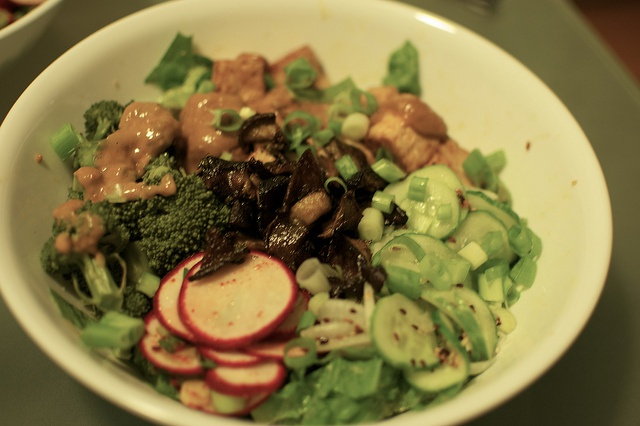Describe the objects in this image and their specific colors. I can see dining table in olive, khaki, black, and tan tones, bowl in maroon, khaki, olive, and black tones, broccoli in maroon, black, and olive tones, broccoli in maroon, black, darkgreen, and olive tones, and broccoli in maroon, olive, and black tones in this image. 